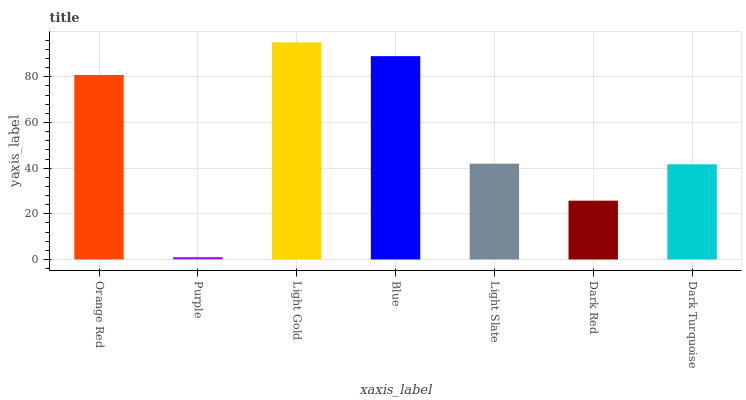Is Light Gold the minimum?
Answer yes or no. No. Is Purple the maximum?
Answer yes or no. No. Is Light Gold greater than Purple?
Answer yes or no. Yes. Is Purple less than Light Gold?
Answer yes or no. Yes. Is Purple greater than Light Gold?
Answer yes or no. No. Is Light Gold less than Purple?
Answer yes or no. No. Is Light Slate the high median?
Answer yes or no. Yes. Is Light Slate the low median?
Answer yes or no. Yes. Is Light Gold the high median?
Answer yes or no. No. Is Purple the low median?
Answer yes or no. No. 